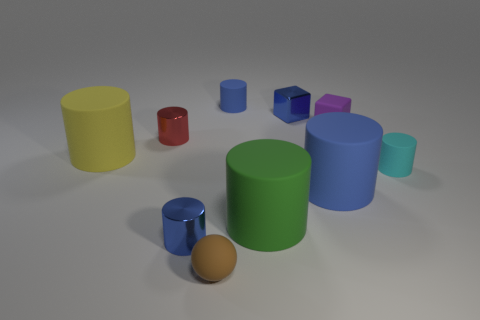There is a large object that is the same color as the metal block; what material is it?
Your answer should be compact. Rubber. Are there any other things that have the same shape as the small blue rubber thing?
Offer a very short reply. Yes. What number of objects are either cylinders to the right of the yellow matte cylinder or tiny blue shiny things?
Your response must be concise. 7. There is a small metal cylinder that is in front of the small cyan object; is it the same color as the tiny matte cube?
Your answer should be compact. No. What shape is the blue thing left of the brown object that is on the right side of the yellow thing?
Your response must be concise. Cylinder. Is the number of tiny blue metal cylinders that are behind the large green rubber cylinder less than the number of small blue cubes in front of the small blue metal cylinder?
Your response must be concise. No. There is a green thing that is the same shape as the small red metal object; what size is it?
Your answer should be very brief. Large. Are there any other things that are the same size as the brown rubber ball?
Your response must be concise. Yes. How many objects are either tiny matte objects on the right side of the small metal block or big objects that are behind the large green matte cylinder?
Your answer should be very brief. 4. Is the matte sphere the same size as the green matte cylinder?
Your answer should be compact. No. 